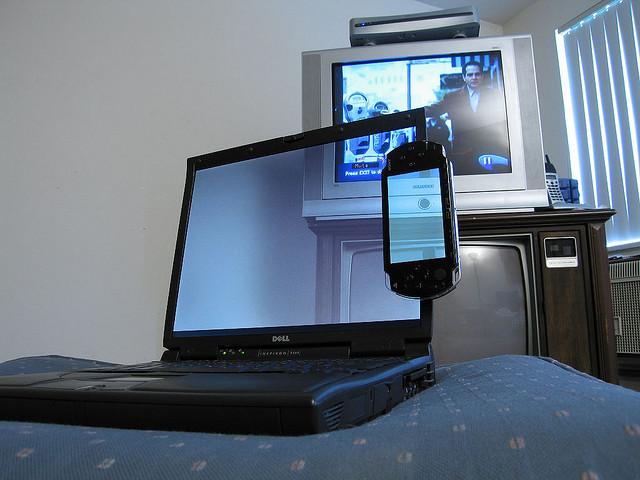How many screens are shown?
Write a very short answer. 4. Are they watching TV through the computer screen?
Quick response, please. Yes. Is this a holographic computer?
Give a very brief answer. Yes. 